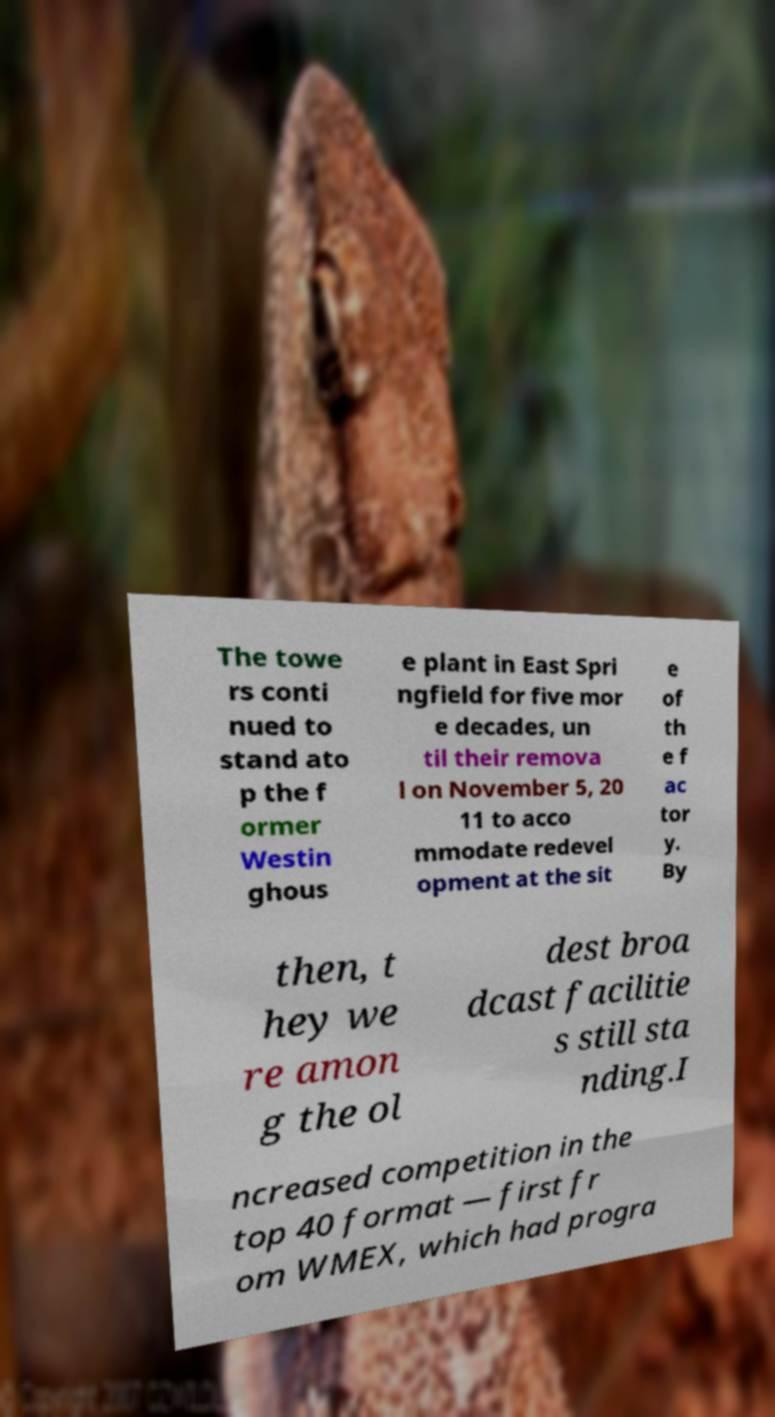Please identify and transcribe the text found in this image. The towe rs conti nued to stand ato p the f ormer Westin ghous e plant in East Spri ngfield for five mor e decades, un til their remova l on November 5, 20 11 to acco mmodate redevel opment at the sit e of th e f ac tor y. By then, t hey we re amon g the ol dest broa dcast facilitie s still sta nding.I ncreased competition in the top 40 format — first fr om WMEX, which had progra 